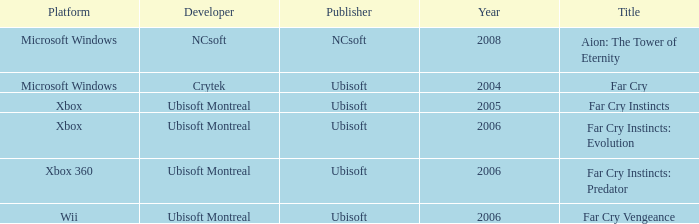What is the average year that has far cry vengeance as the title? 2006.0. 